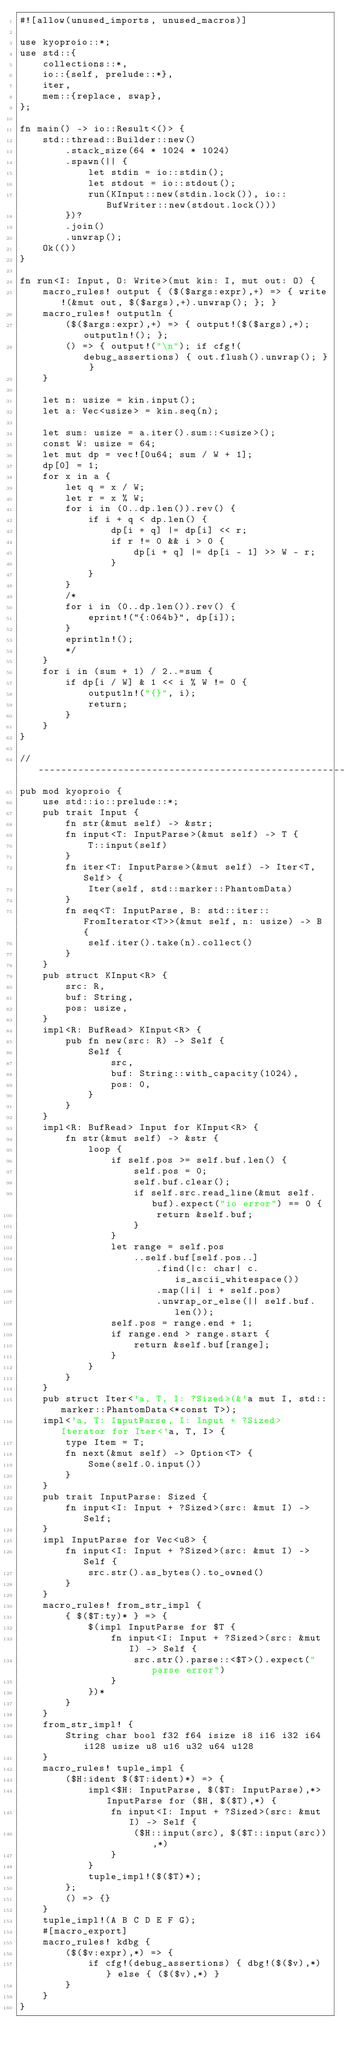<code> <loc_0><loc_0><loc_500><loc_500><_Rust_>#![allow(unused_imports, unused_macros)]

use kyoproio::*;
use std::{
    collections::*,
    io::{self, prelude::*},
    iter,
    mem::{replace, swap},
};

fn main() -> io::Result<()> {
    std::thread::Builder::new()
        .stack_size(64 * 1024 * 1024)
        .spawn(|| {
            let stdin = io::stdin();
            let stdout = io::stdout();
            run(KInput::new(stdin.lock()), io::BufWriter::new(stdout.lock()))
        })?
        .join()
        .unwrap();
    Ok(())
}

fn run<I: Input, O: Write>(mut kin: I, mut out: O) {
    macro_rules! output { ($($args:expr),+) => { write!(&mut out, $($args),+).unwrap(); }; }
    macro_rules! outputln {
        ($($args:expr),+) => { output!($($args),+); outputln!(); };
        () => { output!("\n"); if cfg!(debug_assertions) { out.flush().unwrap(); } }
    }

    let n: usize = kin.input();
    let a: Vec<usize> = kin.seq(n);

    let sum: usize = a.iter().sum::<usize>();
    const W: usize = 64;
    let mut dp = vec![0u64; sum / W + 1];
    dp[0] = 1;
    for x in a {
        let q = x / W;
        let r = x % W;
        for i in (0..dp.len()).rev() {
            if i + q < dp.len() {
                dp[i + q] |= dp[i] << r;
                if r != 0 && i > 0 {
                    dp[i + q] |= dp[i - 1] >> W - r;
                }
            }
        }
        /*
        for i in (0..dp.len()).rev() {
            eprint!("{:064b}", dp[i]);
        }
        eprintln!();
        */
    }
    for i in (sum + 1) / 2..=sum {
        if dp[i / W] & 1 << i % W != 0 {
            outputln!("{}", i);
            return;
        }
    }
}

// -----------------------------------------------------------------------------
pub mod kyoproio {
    use std::io::prelude::*;
    pub trait Input {
        fn str(&mut self) -> &str;
        fn input<T: InputParse>(&mut self) -> T {
            T::input(self)
        }
        fn iter<T: InputParse>(&mut self) -> Iter<T, Self> {
            Iter(self, std::marker::PhantomData)
        }
        fn seq<T: InputParse, B: std::iter::FromIterator<T>>(&mut self, n: usize) -> B {
            self.iter().take(n).collect()
        }
    }
    pub struct KInput<R> {
        src: R,
        buf: String,
        pos: usize,
    }
    impl<R: BufRead> KInput<R> {
        pub fn new(src: R) -> Self {
            Self {
                src,
                buf: String::with_capacity(1024),
                pos: 0,
            }
        }
    }
    impl<R: BufRead> Input for KInput<R> {
        fn str(&mut self) -> &str {
            loop {
                if self.pos >= self.buf.len() {
                    self.pos = 0;
                    self.buf.clear();
                    if self.src.read_line(&mut self.buf).expect("io error") == 0 {
                        return &self.buf;
                    }
                }
                let range = self.pos
                    ..self.buf[self.pos..]
                        .find(|c: char| c.is_ascii_whitespace())
                        .map(|i| i + self.pos)
                        .unwrap_or_else(|| self.buf.len());
                self.pos = range.end + 1;
                if range.end > range.start {
                    return &self.buf[range];
                }
            }
        }
    }
    pub struct Iter<'a, T, I: ?Sized>(&'a mut I, std::marker::PhantomData<*const T>);
    impl<'a, T: InputParse, I: Input + ?Sized> Iterator for Iter<'a, T, I> {
        type Item = T;
        fn next(&mut self) -> Option<T> {
            Some(self.0.input())
        }
    }
    pub trait InputParse: Sized {
        fn input<I: Input + ?Sized>(src: &mut I) -> Self;
    }
    impl InputParse for Vec<u8> {
        fn input<I: Input + ?Sized>(src: &mut I) -> Self {
            src.str().as_bytes().to_owned()
        }
    }
    macro_rules! from_str_impl {
        { $($T:ty)* } => {
            $(impl InputParse for $T {
                fn input<I: Input + ?Sized>(src: &mut I) -> Self {
                    src.str().parse::<$T>().expect("parse error")
                }
            })*
        }
    }
    from_str_impl! {
        String char bool f32 f64 isize i8 i16 i32 i64 i128 usize u8 u16 u32 u64 u128
    }
    macro_rules! tuple_impl {
        ($H:ident $($T:ident)*) => {
            impl<$H: InputParse, $($T: InputParse),*> InputParse for ($H, $($T),*) {
                fn input<I: Input + ?Sized>(src: &mut I) -> Self {
                    ($H::input(src), $($T::input(src)),*)
                }
            }
            tuple_impl!($($T)*);
        };
        () => {}
    }
    tuple_impl!(A B C D E F G);
    #[macro_export]
    macro_rules! kdbg {
        ($($v:expr),*) => {
            if cfg!(debug_assertions) { dbg!($($v),*) } else { ($($v),*) }
        }
    }
}
</code> 